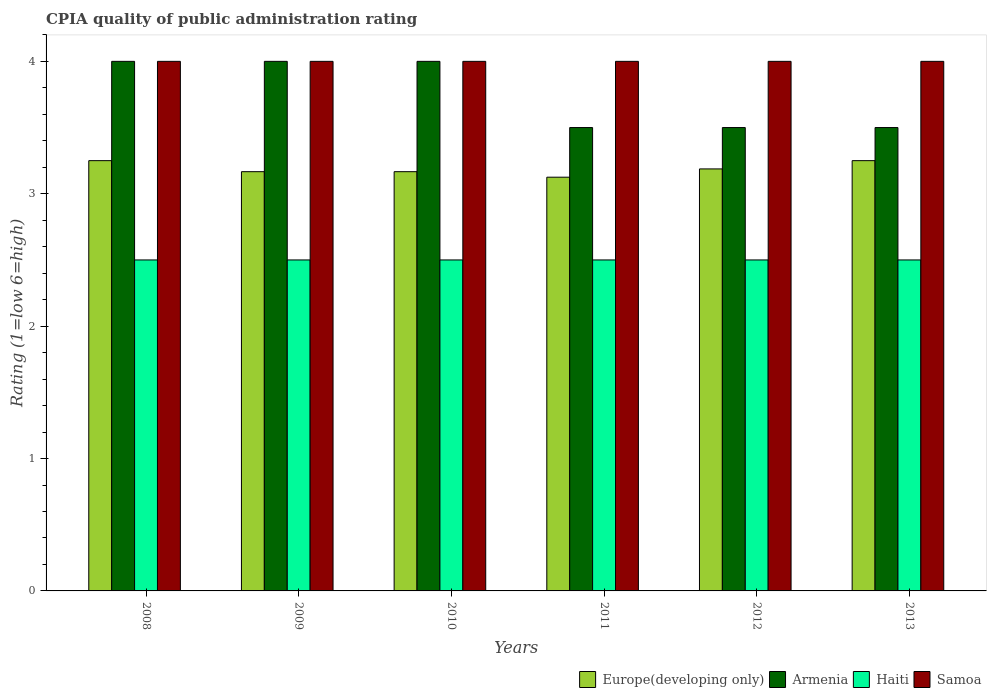How many groups of bars are there?
Offer a very short reply. 6. Are the number of bars per tick equal to the number of legend labels?
Your answer should be very brief. Yes. Are the number of bars on each tick of the X-axis equal?
Keep it short and to the point. Yes. How many bars are there on the 3rd tick from the left?
Your answer should be compact. 4. In how many cases, is the number of bars for a given year not equal to the number of legend labels?
Provide a succinct answer. 0. What is the CPIA rating in Europe(developing only) in 2010?
Provide a short and direct response. 3.17. Across all years, what is the minimum CPIA rating in Europe(developing only)?
Offer a terse response. 3.12. In which year was the CPIA rating in Europe(developing only) maximum?
Your answer should be compact. 2008. What is the total CPIA rating in Samoa in the graph?
Offer a terse response. 24. What is the difference between the CPIA rating in Samoa in 2010 and the CPIA rating in Europe(developing only) in 2012?
Make the answer very short. 0.81. What is the average CPIA rating in Haiti per year?
Ensure brevity in your answer.  2.5. What is the ratio of the CPIA rating in Armenia in 2008 to that in 2011?
Your answer should be very brief. 1.14. What is the difference between the highest and the second highest CPIA rating in Europe(developing only)?
Make the answer very short. 0. What is the difference between the highest and the lowest CPIA rating in Samoa?
Keep it short and to the point. 0. In how many years, is the CPIA rating in Samoa greater than the average CPIA rating in Samoa taken over all years?
Ensure brevity in your answer.  0. Is the sum of the CPIA rating in Haiti in 2009 and 2013 greater than the maximum CPIA rating in Samoa across all years?
Your answer should be very brief. Yes. Is it the case that in every year, the sum of the CPIA rating in Haiti and CPIA rating in Armenia is greater than the sum of CPIA rating in Europe(developing only) and CPIA rating in Samoa?
Your response must be concise. Yes. What does the 3rd bar from the left in 2012 represents?
Provide a short and direct response. Haiti. What does the 4th bar from the right in 2009 represents?
Your answer should be compact. Europe(developing only). Is it the case that in every year, the sum of the CPIA rating in Samoa and CPIA rating in Europe(developing only) is greater than the CPIA rating in Haiti?
Keep it short and to the point. Yes. How many bars are there?
Your answer should be very brief. 24. Are all the bars in the graph horizontal?
Your answer should be very brief. No. How many years are there in the graph?
Make the answer very short. 6. What is the difference between two consecutive major ticks on the Y-axis?
Offer a very short reply. 1. Are the values on the major ticks of Y-axis written in scientific E-notation?
Your answer should be very brief. No. Does the graph contain any zero values?
Give a very brief answer. No. Where does the legend appear in the graph?
Offer a terse response. Bottom right. What is the title of the graph?
Offer a terse response. CPIA quality of public administration rating. What is the label or title of the X-axis?
Your response must be concise. Years. What is the Rating (1=low 6=high) in Europe(developing only) in 2009?
Your answer should be compact. 3.17. What is the Rating (1=low 6=high) in Samoa in 2009?
Provide a succinct answer. 4. What is the Rating (1=low 6=high) of Europe(developing only) in 2010?
Your answer should be compact. 3.17. What is the Rating (1=low 6=high) in Armenia in 2010?
Offer a very short reply. 4. What is the Rating (1=low 6=high) in Haiti in 2010?
Offer a terse response. 2.5. What is the Rating (1=low 6=high) of Europe(developing only) in 2011?
Offer a terse response. 3.12. What is the Rating (1=low 6=high) in Samoa in 2011?
Keep it short and to the point. 4. What is the Rating (1=low 6=high) in Europe(developing only) in 2012?
Your answer should be compact. 3.19. What is the Rating (1=low 6=high) of Haiti in 2012?
Ensure brevity in your answer.  2.5. What is the Rating (1=low 6=high) in Haiti in 2013?
Your answer should be compact. 2.5. What is the Rating (1=low 6=high) in Samoa in 2013?
Your answer should be very brief. 4. Across all years, what is the maximum Rating (1=low 6=high) in Armenia?
Your answer should be very brief. 4. Across all years, what is the maximum Rating (1=low 6=high) of Haiti?
Keep it short and to the point. 2.5. Across all years, what is the maximum Rating (1=low 6=high) in Samoa?
Your response must be concise. 4. Across all years, what is the minimum Rating (1=low 6=high) in Europe(developing only)?
Your answer should be compact. 3.12. Across all years, what is the minimum Rating (1=low 6=high) in Haiti?
Provide a short and direct response. 2.5. Across all years, what is the minimum Rating (1=low 6=high) of Samoa?
Offer a terse response. 4. What is the total Rating (1=low 6=high) in Europe(developing only) in the graph?
Make the answer very short. 19.15. What is the total Rating (1=low 6=high) in Haiti in the graph?
Make the answer very short. 15. What is the total Rating (1=low 6=high) in Samoa in the graph?
Offer a terse response. 24. What is the difference between the Rating (1=low 6=high) in Europe(developing only) in 2008 and that in 2009?
Offer a very short reply. 0.08. What is the difference between the Rating (1=low 6=high) in Armenia in 2008 and that in 2009?
Your answer should be compact. 0. What is the difference between the Rating (1=low 6=high) of Haiti in 2008 and that in 2009?
Ensure brevity in your answer.  0. What is the difference between the Rating (1=low 6=high) in Samoa in 2008 and that in 2009?
Your response must be concise. 0. What is the difference between the Rating (1=low 6=high) in Europe(developing only) in 2008 and that in 2010?
Ensure brevity in your answer.  0.08. What is the difference between the Rating (1=low 6=high) of Armenia in 2008 and that in 2011?
Your answer should be very brief. 0.5. What is the difference between the Rating (1=low 6=high) of Haiti in 2008 and that in 2011?
Offer a terse response. 0. What is the difference between the Rating (1=low 6=high) of Samoa in 2008 and that in 2011?
Provide a short and direct response. 0. What is the difference between the Rating (1=low 6=high) of Europe(developing only) in 2008 and that in 2012?
Ensure brevity in your answer.  0.06. What is the difference between the Rating (1=low 6=high) in Armenia in 2008 and that in 2012?
Make the answer very short. 0.5. What is the difference between the Rating (1=low 6=high) in Samoa in 2008 and that in 2012?
Ensure brevity in your answer.  0. What is the difference between the Rating (1=low 6=high) in Europe(developing only) in 2008 and that in 2013?
Provide a short and direct response. 0. What is the difference between the Rating (1=low 6=high) of Armenia in 2008 and that in 2013?
Give a very brief answer. 0.5. What is the difference between the Rating (1=low 6=high) of Haiti in 2008 and that in 2013?
Offer a terse response. 0. What is the difference between the Rating (1=low 6=high) of Samoa in 2008 and that in 2013?
Provide a succinct answer. 0. What is the difference between the Rating (1=low 6=high) of Europe(developing only) in 2009 and that in 2010?
Offer a terse response. 0. What is the difference between the Rating (1=low 6=high) in Haiti in 2009 and that in 2010?
Ensure brevity in your answer.  0. What is the difference between the Rating (1=low 6=high) of Samoa in 2009 and that in 2010?
Keep it short and to the point. 0. What is the difference between the Rating (1=low 6=high) of Europe(developing only) in 2009 and that in 2011?
Your response must be concise. 0.04. What is the difference between the Rating (1=low 6=high) of Armenia in 2009 and that in 2011?
Offer a terse response. 0.5. What is the difference between the Rating (1=low 6=high) in Europe(developing only) in 2009 and that in 2012?
Keep it short and to the point. -0.02. What is the difference between the Rating (1=low 6=high) of Armenia in 2009 and that in 2012?
Offer a terse response. 0.5. What is the difference between the Rating (1=low 6=high) in Haiti in 2009 and that in 2012?
Make the answer very short. 0. What is the difference between the Rating (1=low 6=high) of Samoa in 2009 and that in 2012?
Give a very brief answer. 0. What is the difference between the Rating (1=low 6=high) in Europe(developing only) in 2009 and that in 2013?
Your response must be concise. -0.08. What is the difference between the Rating (1=low 6=high) in Samoa in 2009 and that in 2013?
Your answer should be compact. 0. What is the difference between the Rating (1=low 6=high) in Europe(developing only) in 2010 and that in 2011?
Make the answer very short. 0.04. What is the difference between the Rating (1=low 6=high) of Armenia in 2010 and that in 2011?
Make the answer very short. 0.5. What is the difference between the Rating (1=low 6=high) of Europe(developing only) in 2010 and that in 2012?
Ensure brevity in your answer.  -0.02. What is the difference between the Rating (1=low 6=high) of Europe(developing only) in 2010 and that in 2013?
Keep it short and to the point. -0.08. What is the difference between the Rating (1=low 6=high) in Armenia in 2010 and that in 2013?
Provide a short and direct response. 0.5. What is the difference between the Rating (1=low 6=high) in Haiti in 2010 and that in 2013?
Give a very brief answer. 0. What is the difference between the Rating (1=low 6=high) of Samoa in 2010 and that in 2013?
Provide a short and direct response. 0. What is the difference between the Rating (1=low 6=high) in Europe(developing only) in 2011 and that in 2012?
Keep it short and to the point. -0.06. What is the difference between the Rating (1=low 6=high) of Europe(developing only) in 2011 and that in 2013?
Your response must be concise. -0.12. What is the difference between the Rating (1=low 6=high) of Haiti in 2011 and that in 2013?
Offer a very short reply. 0. What is the difference between the Rating (1=low 6=high) in Samoa in 2011 and that in 2013?
Provide a short and direct response. 0. What is the difference between the Rating (1=low 6=high) of Europe(developing only) in 2012 and that in 2013?
Provide a short and direct response. -0.06. What is the difference between the Rating (1=low 6=high) of Armenia in 2012 and that in 2013?
Ensure brevity in your answer.  0. What is the difference between the Rating (1=low 6=high) in Europe(developing only) in 2008 and the Rating (1=low 6=high) in Armenia in 2009?
Make the answer very short. -0.75. What is the difference between the Rating (1=low 6=high) of Europe(developing only) in 2008 and the Rating (1=low 6=high) of Samoa in 2009?
Your answer should be compact. -0.75. What is the difference between the Rating (1=low 6=high) of Armenia in 2008 and the Rating (1=low 6=high) of Haiti in 2009?
Your answer should be very brief. 1.5. What is the difference between the Rating (1=low 6=high) in Armenia in 2008 and the Rating (1=low 6=high) in Samoa in 2009?
Give a very brief answer. 0. What is the difference between the Rating (1=low 6=high) in Haiti in 2008 and the Rating (1=low 6=high) in Samoa in 2009?
Your answer should be compact. -1.5. What is the difference between the Rating (1=low 6=high) in Europe(developing only) in 2008 and the Rating (1=low 6=high) in Armenia in 2010?
Keep it short and to the point. -0.75. What is the difference between the Rating (1=low 6=high) in Europe(developing only) in 2008 and the Rating (1=low 6=high) in Haiti in 2010?
Your response must be concise. 0.75. What is the difference between the Rating (1=low 6=high) of Europe(developing only) in 2008 and the Rating (1=low 6=high) of Samoa in 2010?
Offer a very short reply. -0.75. What is the difference between the Rating (1=low 6=high) of Armenia in 2008 and the Rating (1=low 6=high) of Haiti in 2010?
Make the answer very short. 1.5. What is the difference between the Rating (1=low 6=high) of Europe(developing only) in 2008 and the Rating (1=low 6=high) of Armenia in 2011?
Make the answer very short. -0.25. What is the difference between the Rating (1=low 6=high) in Europe(developing only) in 2008 and the Rating (1=low 6=high) in Samoa in 2011?
Give a very brief answer. -0.75. What is the difference between the Rating (1=low 6=high) of Armenia in 2008 and the Rating (1=low 6=high) of Haiti in 2011?
Make the answer very short. 1.5. What is the difference between the Rating (1=low 6=high) of Haiti in 2008 and the Rating (1=low 6=high) of Samoa in 2011?
Give a very brief answer. -1.5. What is the difference between the Rating (1=low 6=high) in Europe(developing only) in 2008 and the Rating (1=low 6=high) in Armenia in 2012?
Provide a short and direct response. -0.25. What is the difference between the Rating (1=low 6=high) in Europe(developing only) in 2008 and the Rating (1=low 6=high) in Haiti in 2012?
Ensure brevity in your answer.  0.75. What is the difference between the Rating (1=low 6=high) of Europe(developing only) in 2008 and the Rating (1=low 6=high) of Samoa in 2012?
Offer a terse response. -0.75. What is the difference between the Rating (1=low 6=high) in Armenia in 2008 and the Rating (1=low 6=high) in Haiti in 2012?
Offer a very short reply. 1.5. What is the difference between the Rating (1=low 6=high) in Europe(developing only) in 2008 and the Rating (1=low 6=high) in Armenia in 2013?
Provide a succinct answer. -0.25. What is the difference between the Rating (1=low 6=high) of Europe(developing only) in 2008 and the Rating (1=low 6=high) of Haiti in 2013?
Offer a very short reply. 0.75. What is the difference between the Rating (1=low 6=high) in Europe(developing only) in 2008 and the Rating (1=low 6=high) in Samoa in 2013?
Make the answer very short. -0.75. What is the difference between the Rating (1=low 6=high) of Armenia in 2008 and the Rating (1=low 6=high) of Haiti in 2013?
Provide a succinct answer. 1.5. What is the difference between the Rating (1=low 6=high) of Armenia in 2008 and the Rating (1=low 6=high) of Samoa in 2013?
Provide a short and direct response. 0. What is the difference between the Rating (1=low 6=high) of Europe(developing only) in 2009 and the Rating (1=low 6=high) of Haiti in 2010?
Provide a succinct answer. 0.67. What is the difference between the Rating (1=low 6=high) of Europe(developing only) in 2009 and the Rating (1=low 6=high) of Samoa in 2010?
Offer a very short reply. -0.83. What is the difference between the Rating (1=low 6=high) of Armenia in 2009 and the Rating (1=low 6=high) of Haiti in 2010?
Keep it short and to the point. 1.5. What is the difference between the Rating (1=low 6=high) in Armenia in 2009 and the Rating (1=low 6=high) in Samoa in 2010?
Your answer should be compact. 0. What is the difference between the Rating (1=low 6=high) of Europe(developing only) in 2009 and the Rating (1=low 6=high) of Haiti in 2011?
Your answer should be very brief. 0.67. What is the difference between the Rating (1=low 6=high) of Europe(developing only) in 2009 and the Rating (1=low 6=high) of Samoa in 2011?
Your response must be concise. -0.83. What is the difference between the Rating (1=low 6=high) of Armenia in 2009 and the Rating (1=low 6=high) of Samoa in 2011?
Give a very brief answer. 0. What is the difference between the Rating (1=low 6=high) in Europe(developing only) in 2009 and the Rating (1=low 6=high) in Armenia in 2012?
Give a very brief answer. -0.33. What is the difference between the Rating (1=low 6=high) of Europe(developing only) in 2009 and the Rating (1=low 6=high) of Haiti in 2012?
Offer a very short reply. 0.67. What is the difference between the Rating (1=low 6=high) of Europe(developing only) in 2009 and the Rating (1=low 6=high) of Samoa in 2012?
Provide a short and direct response. -0.83. What is the difference between the Rating (1=low 6=high) of Armenia in 2009 and the Rating (1=low 6=high) of Samoa in 2012?
Provide a short and direct response. 0. What is the difference between the Rating (1=low 6=high) of Haiti in 2009 and the Rating (1=low 6=high) of Samoa in 2012?
Your answer should be compact. -1.5. What is the difference between the Rating (1=low 6=high) in Europe(developing only) in 2009 and the Rating (1=low 6=high) in Armenia in 2013?
Offer a very short reply. -0.33. What is the difference between the Rating (1=low 6=high) in Europe(developing only) in 2009 and the Rating (1=low 6=high) in Haiti in 2013?
Provide a succinct answer. 0.67. What is the difference between the Rating (1=low 6=high) in Europe(developing only) in 2009 and the Rating (1=low 6=high) in Samoa in 2013?
Offer a very short reply. -0.83. What is the difference between the Rating (1=low 6=high) of Armenia in 2009 and the Rating (1=low 6=high) of Samoa in 2013?
Ensure brevity in your answer.  0. What is the difference between the Rating (1=low 6=high) in Europe(developing only) in 2010 and the Rating (1=low 6=high) in Armenia in 2011?
Ensure brevity in your answer.  -0.33. What is the difference between the Rating (1=low 6=high) of Europe(developing only) in 2010 and the Rating (1=low 6=high) of Haiti in 2011?
Make the answer very short. 0.67. What is the difference between the Rating (1=low 6=high) of Armenia in 2010 and the Rating (1=low 6=high) of Haiti in 2011?
Your answer should be very brief. 1.5. What is the difference between the Rating (1=low 6=high) in Armenia in 2010 and the Rating (1=low 6=high) in Samoa in 2011?
Offer a very short reply. 0. What is the difference between the Rating (1=low 6=high) of Armenia in 2010 and the Rating (1=low 6=high) of Haiti in 2012?
Your response must be concise. 1.5. What is the difference between the Rating (1=low 6=high) of Armenia in 2010 and the Rating (1=low 6=high) of Samoa in 2012?
Ensure brevity in your answer.  0. What is the difference between the Rating (1=low 6=high) of Europe(developing only) in 2010 and the Rating (1=low 6=high) of Haiti in 2013?
Ensure brevity in your answer.  0.67. What is the difference between the Rating (1=low 6=high) of Haiti in 2010 and the Rating (1=low 6=high) of Samoa in 2013?
Offer a very short reply. -1.5. What is the difference between the Rating (1=low 6=high) of Europe(developing only) in 2011 and the Rating (1=low 6=high) of Armenia in 2012?
Offer a terse response. -0.38. What is the difference between the Rating (1=low 6=high) in Europe(developing only) in 2011 and the Rating (1=low 6=high) in Haiti in 2012?
Your answer should be very brief. 0.62. What is the difference between the Rating (1=low 6=high) in Europe(developing only) in 2011 and the Rating (1=low 6=high) in Samoa in 2012?
Make the answer very short. -0.88. What is the difference between the Rating (1=low 6=high) of Armenia in 2011 and the Rating (1=low 6=high) of Haiti in 2012?
Ensure brevity in your answer.  1. What is the difference between the Rating (1=low 6=high) in Armenia in 2011 and the Rating (1=low 6=high) in Samoa in 2012?
Your answer should be very brief. -0.5. What is the difference between the Rating (1=low 6=high) of Haiti in 2011 and the Rating (1=low 6=high) of Samoa in 2012?
Offer a very short reply. -1.5. What is the difference between the Rating (1=low 6=high) in Europe(developing only) in 2011 and the Rating (1=low 6=high) in Armenia in 2013?
Offer a very short reply. -0.38. What is the difference between the Rating (1=low 6=high) of Europe(developing only) in 2011 and the Rating (1=low 6=high) of Samoa in 2013?
Offer a very short reply. -0.88. What is the difference between the Rating (1=low 6=high) in Europe(developing only) in 2012 and the Rating (1=low 6=high) in Armenia in 2013?
Offer a very short reply. -0.31. What is the difference between the Rating (1=low 6=high) in Europe(developing only) in 2012 and the Rating (1=low 6=high) in Haiti in 2013?
Give a very brief answer. 0.69. What is the difference between the Rating (1=low 6=high) in Europe(developing only) in 2012 and the Rating (1=low 6=high) in Samoa in 2013?
Provide a short and direct response. -0.81. What is the difference between the Rating (1=low 6=high) of Armenia in 2012 and the Rating (1=low 6=high) of Samoa in 2013?
Give a very brief answer. -0.5. What is the difference between the Rating (1=low 6=high) of Haiti in 2012 and the Rating (1=low 6=high) of Samoa in 2013?
Make the answer very short. -1.5. What is the average Rating (1=low 6=high) of Europe(developing only) per year?
Give a very brief answer. 3.19. What is the average Rating (1=low 6=high) in Armenia per year?
Your answer should be very brief. 3.75. What is the average Rating (1=low 6=high) of Samoa per year?
Make the answer very short. 4. In the year 2008, what is the difference between the Rating (1=low 6=high) in Europe(developing only) and Rating (1=low 6=high) in Armenia?
Keep it short and to the point. -0.75. In the year 2008, what is the difference between the Rating (1=low 6=high) of Europe(developing only) and Rating (1=low 6=high) of Samoa?
Ensure brevity in your answer.  -0.75. In the year 2008, what is the difference between the Rating (1=low 6=high) in Haiti and Rating (1=low 6=high) in Samoa?
Provide a short and direct response. -1.5. In the year 2009, what is the difference between the Rating (1=low 6=high) of Europe(developing only) and Rating (1=low 6=high) of Haiti?
Provide a succinct answer. 0.67. In the year 2009, what is the difference between the Rating (1=low 6=high) in Europe(developing only) and Rating (1=low 6=high) in Samoa?
Provide a short and direct response. -0.83. In the year 2009, what is the difference between the Rating (1=low 6=high) of Armenia and Rating (1=low 6=high) of Samoa?
Make the answer very short. 0. In the year 2010, what is the difference between the Rating (1=low 6=high) of Europe(developing only) and Rating (1=low 6=high) of Armenia?
Your answer should be very brief. -0.83. In the year 2010, what is the difference between the Rating (1=low 6=high) of Haiti and Rating (1=low 6=high) of Samoa?
Your answer should be compact. -1.5. In the year 2011, what is the difference between the Rating (1=low 6=high) in Europe(developing only) and Rating (1=low 6=high) in Armenia?
Offer a very short reply. -0.38. In the year 2011, what is the difference between the Rating (1=low 6=high) of Europe(developing only) and Rating (1=low 6=high) of Samoa?
Make the answer very short. -0.88. In the year 2011, what is the difference between the Rating (1=low 6=high) of Armenia and Rating (1=low 6=high) of Haiti?
Ensure brevity in your answer.  1. In the year 2011, what is the difference between the Rating (1=low 6=high) of Armenia and Rating (1=low 6=high) of Samoa?
Keep it short and to the point. -0.5. In the year 2011, what is the difference between the Rating (1=low 6=high) of Haiti and Rating (1=low 6=high) of Samoa?
Keep it short and to the point. -1.5. In the year 2012, what is the difference between the Rating (1=low 6=high) in Europe(developing only) and Rating (1=low 6=high) in Armenia?
Make the answer very short. -0.31. In the year 2012, what is the difference between the Rating (1=low 6=high) in Europe(developing only) and Rating (1=low 6=high) in Haiti?
Give a very brief answer. 0.69. In the year 2012, what is the difference between the Rating (1=low 6=high) of Europe(developing only) and Rating (1=low 6=high) of Samoa?
Your answer should be very brief. -0.81. In the year 2013, what is the difference between the Rating (1=low 6=high) of Europe(developing only) and Rating (1=low 6=high) of Samoa?
Provide a succinct answer. -0.75. In the year 2013, what is the difference between the Rating (1=low 6=high) in Haiti and Rating (1=low 6=high) in Samoa?
Offer a very short reply. -1.5. What is the ratio of the Rating (1=low 6=high) of Europe(developing only) in 2008 to that in 2009?
Make the answer very short. 1.03. What is the ratio of the Rating (1=low 6=high) in Armenia in 2008 to that in 2009?
Make the answer very short. 1. What is the ratio of the Rating (1=low 6=high) in Samoa in 2008 to that in 2009?
Give a very brief answer. 1. What is the ratio of the Rating (1=low 6=high) in Europe(developing only) in 2008 to that in 2010?
Your response must be concise. 1.03. What is the ratio of the Rating (1=low 6=high) in Armenia in 2008 to that in 2010?
Offer a very short reply. 1. What is the ratio of the Rating (1=low 6=high) in Samoa in 2008 to that in 2010?
Keep it short and to the point. 1. What is the ratio of the Rating (1=low 6=high) of Europe(developing only) in 2008 to that in 2011?
Your answer should be compact. 1.04. What is the ratio of the Rating (1=low 6=high) in Armenia in 2008 to that in 2011?
Your answer should be compact. 1.14. What is the ratio of the Rating (1=low 6=high) in Haiti in 2008 to that in 2011?
Ensure brevity in your answer.  1. What is the ratio of the Rating (1=low 6=high) in Samoa in 2008 to that in 2011?
Make the answer very short. 1. What is the ratio of the Rating (1=low 6=high) in Europe(developing only) in 2008 to that in 2012?
Provide a succinct answer. 1.02. What is the ratio of the Rating (1=low 6=high) of Armenia in 2008 to that in 2012?
Give a very brief answer. 1.14. What is the ratio of the Rating (1=low 6=high) in Europe(developing only) in 2008 to that in 2013?
Your answer should be compact. 1. What is the ratio of the Rating (1=low 6=high) in Armenia in 2008 to that in 2013?
Offer a very short reply. 1.14. What is the ratio of the Rating (1=low 6=high) of Haiti in 2008 to that in 2013?
Make the answer very short. 1. What is the ratio of the Rating (1=low 6=high) in Samoa in 2008 to that in 2013?
Ensure brevity in your answer.  1. What is the ratio of the Rating (1=low 6=high) in Armenia in 2009 to that in 2010?
Your response must be concise. 1. What is the ratio of the Rating (1=low 6=high) in Haiti in 2009 to that in 2010?
Ensure brevity in your answer.  1. What is the ratio of the Rating (1=low 6=high) of Europe(developing only) in 2009 to that in 2011?
Make the answer very short. 1.01. What is the ratio of the Rating (1=low 6=high) of Armenia in 2009 to that in 2011?
Keep it short and to the point. 1.14. What is the ratio of the Rating (1=low 6=high) of Haiti in 2009 to that in 2012?
Give a very brief answer. 1. What is the ratio of the Rating (1=low 6=high) of Samoa in 2009 to that in 2012?
Offer a terse response. 1. What is the ratio of the Rating (1=low 6=high) in Europe(developing only) in 2009 to that in 2013?
Offer a terse response. 0.97. What is the ratio of the Rating (1=low 6=high) of Armenia in 2009 to that in 2013?
Your response must be concise. 1.14. What is the ratio of the Rating (1=low 6=high) in Haiti in 2009 to that in 2013?
Provide a succinct answer. 1. What is the ratio of the Rating (1=low 6=high) in Samoa in 2009 to that in 2013?
Offer a terse response. 1. What is the ratio of the Rating (1=low 6=high) in Europe(developing only) in 2010 to that in 2011?
Ensure brevity in your answer.  1.01. What is the ratio of the Rating (1=low 6=high) in Armenia in 2010 to that in 2011?
Offer a very short reply. 1.14. What is the ratio of the Rating (1=low 6=high) in Haiti in 2010 to that in 2011?
Make the answer very short. 1. What is the ratio of the Rating (1=low 6=high) of Samoa in 2010 to that in 2011?
Make the answer very short. 1. What is the ratio of the Rating (1=low 6=high) of Armenia in 2010 to that in 2012?
Make the answer very short. 1.14. What is the ratio of the Rating (1=low 6=high) of Haiti in 2010 to that in 2012?
Ensure brevity in your answer.  1. What is the ratio of the Rating (1=low 6=high) of Samoa in 2010 to that in 2012?
Keep it short and to the point. 1. What is the ratio of the Rating (1=low 6=high) in Europe(developing only) in 2010 to that in 2013?
Provide a short and direct response. 0.97. What is the ratio of the Rating (1=low 6=high) in Haiti in 2010 to that in 2013?
Offer a very short reply. 1. What is the ratio of the Rating (1=low 6=high) of Samoa in 2010 to that in 2013?
Your answer should be compact. 1. What is the ratio of the Rating (1=low 6=high) of Europe(developing only) in 2011 to that in 2012?
Ensure brevity in your answer.  0.98. What is the ratio of the Rating (1=low 6=high) of Haiti in 2011 to that in 2012?
Ensure brevity in your answer.  1. What is the ratio of the Rating (1=low 6=high) of Europe(developing only) in 2011 to that in 2013?
Provide a succinct answer. 0.96. What is the ratio of the Rating (1=low 6=high) in Armenia in 2011 to that in 2013?
Offer a very short reply. 1. What is the ratio of the Rating (1=low 6=high) of Haiti in 2011 to that in 2013?
Give a very brief answer. 1. What is the ratio of the Rating (1=low 6=high) of Europe(developing only) in 2012 to that in 2013?
Offer a terse response. 0.98. What is the ratio of the Rating (1=low 6=high) in Haiti in 2012 to that in 2013?
Offer a very short reply. 1. What is the difference between the highest and the second highest Rating (1=low 6=high) of Armenia?
Offer a terse response. 0. What is the difference between the highest and the second highest Rating (1=low 6=high) in Samoa?
Keep it short and to the point. 0. What is the difference between the highest and the lowest Rating (1=low 6=high) of Europe(developing only)?
Your response must be concise. 0.12. What is the difference between the highest and the lowest Rating (1=low 6=high) of Armenia?
Provide a succinct answer. 0.5. What is the difference between the highest and the lowest Rating (1=low 6=high) of Haiti?
Provide a succinct answer. 0. What is the difference between the highest and the lowest Rating (1=low 6=high) in Samoa?
Make the answer very short. 0. 